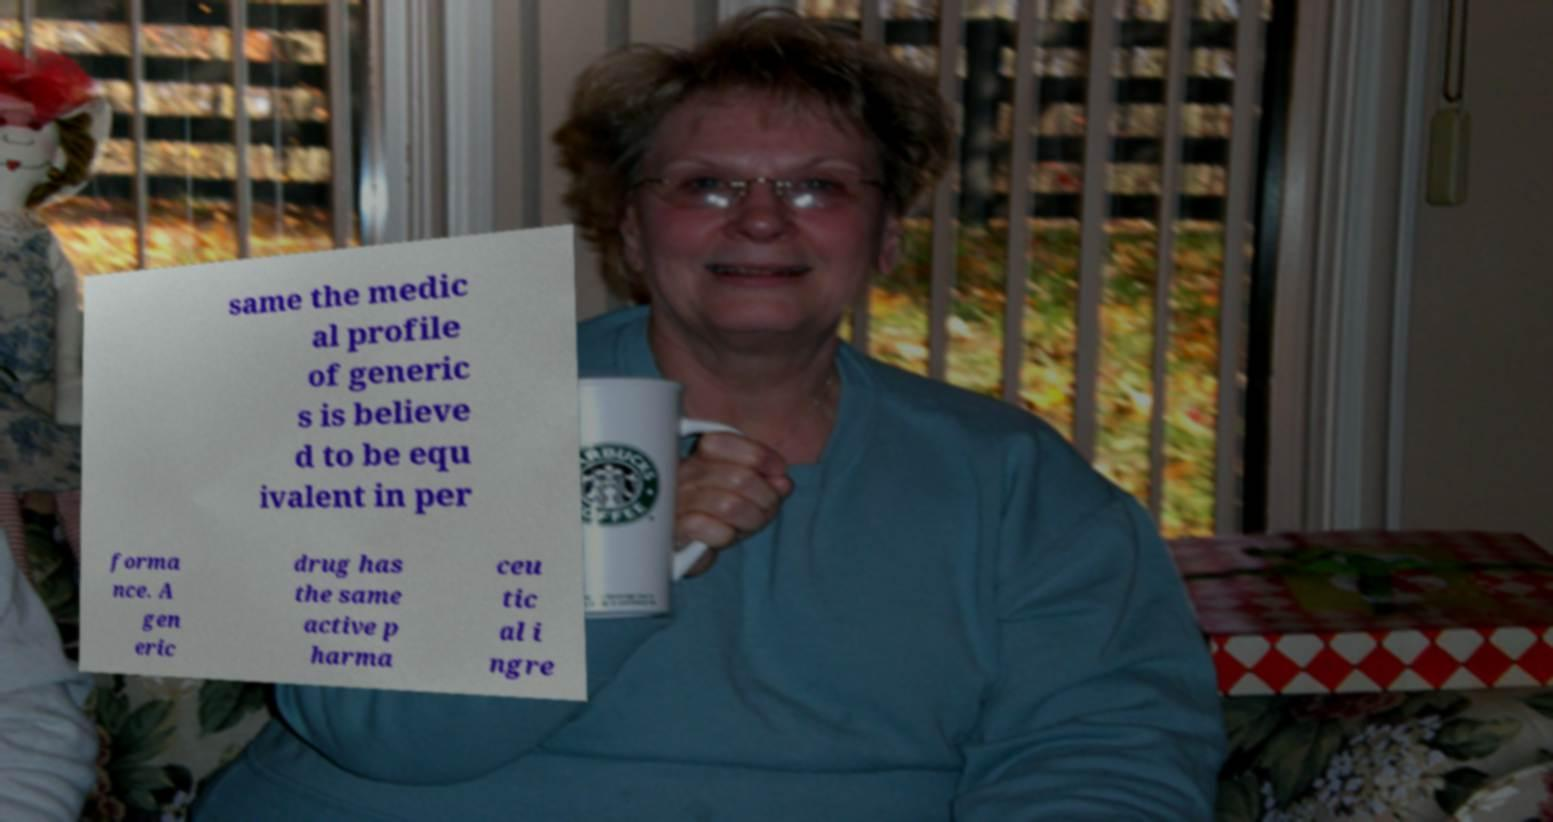Could you assist in decoding the text presented in this image and type it out clearly? same the medic al profile of generic s is believe d to be equ ivalent in per forma nce. A gen eric drug has the same active p harma ceu tic al i ngre 